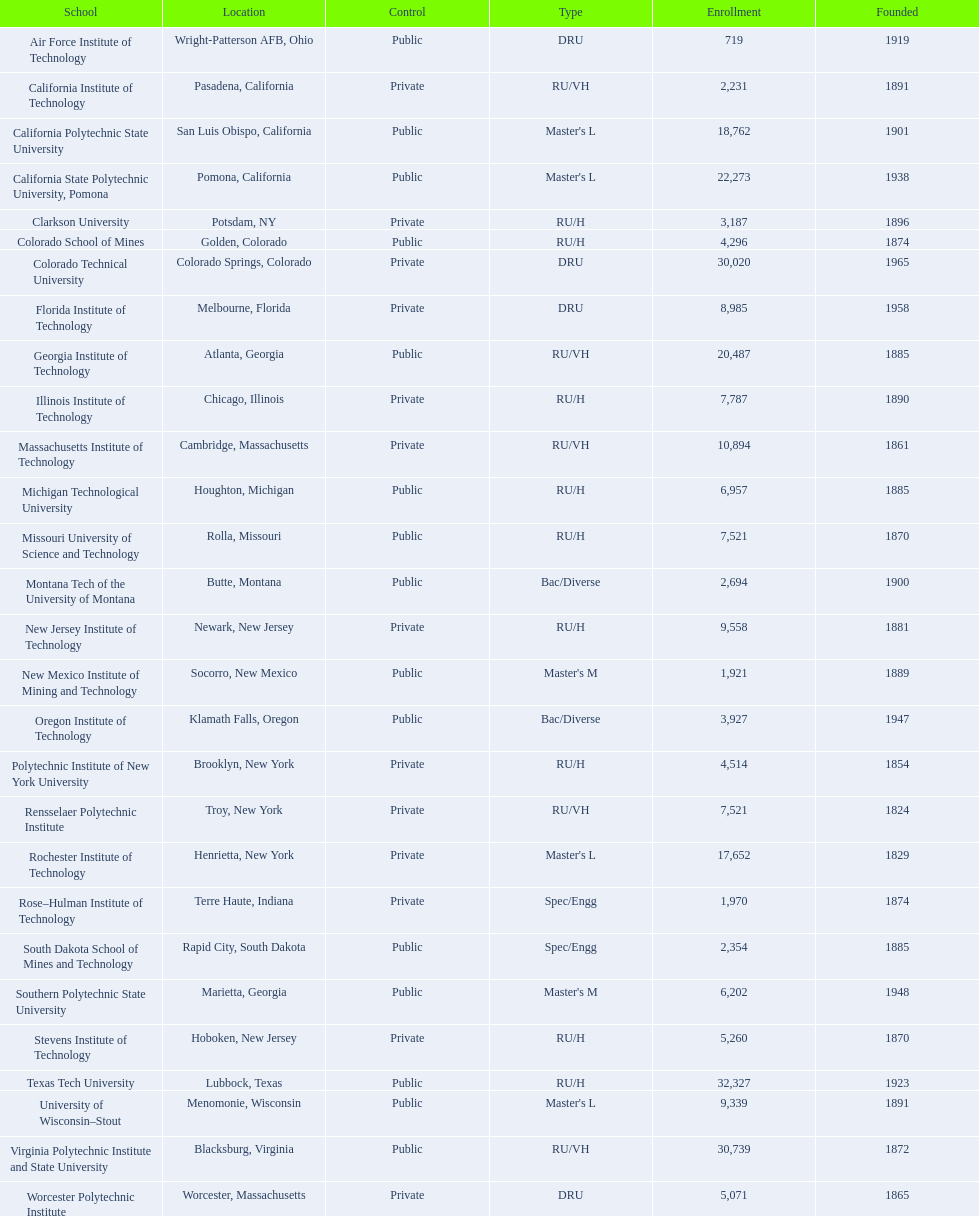What are the recorded registration figures for us colleges? 719, 2,231, 18,762, 22,273, 3,187, 4,296, 30,020, 8,985, 20,487, 7,787, 10,894, 6,957, 7,521, 2,694, 9,558, 1,921, 3,927, 4,514, 7,521, 17,652, 1,970, 2,354, 6,202, 5,260, 32,327, 9,339, 30,739, 5,071. Among them, which has the greatest number? 32,327. What are the documented names of us colleges? Air Force Institute of Technology, California Institute of Technology, California Polytechnic State University, California State Polytechnic University, Pomona, Clarkson University, Colorado School of Mines, Colorado Technical University, Florida Institute of Technology, Georgia Institute of Technology, Illinois Institute of Technology, Massachusetts Institute of Technology, Michigan Technological University, Missouri University of Science and Technology, Montana Tech of the University of Montana, New Jersey Institute of Technology, New Mexico Institute of Mining and Technology, Oregon Institute of Technology, Polytechnic Institute of New York University, Rensselaer Polytechnic Institute, Rochester Institute of Technology, Rose–Hulman Institute of Technology, South Dakota School of Mines and Technology, Southern Polytechnic State University, Stevens Institute of Technology, Texas Tech University, University of Wisconsin–Stout, Virginia Polytechnic Institute and State University, Worcester Polytechnic Institute. Which of these match the earlier mentioned highest enrollment figure? Texas Tech University. 